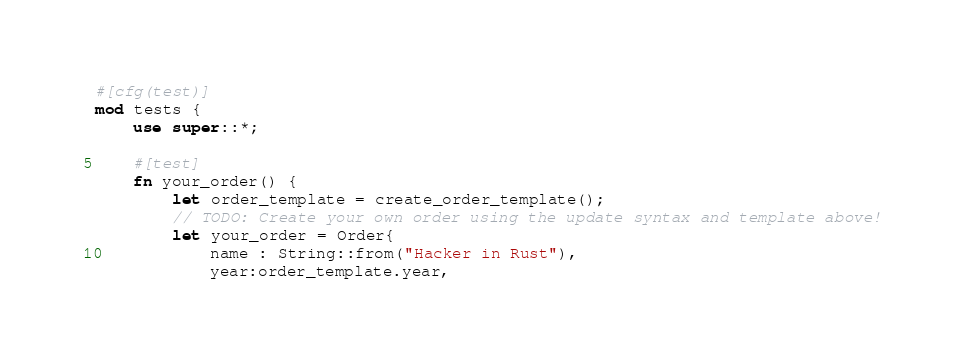Convert code to text. <code><loc_0><loc_0><loc_500><loc_500><_Rust_>#[cfg(test)]
mod tests {
    use super::*;

    #[test]
    fn your_order() {
        let order_template = create_order_template();
        // TODO: Create your own order using the update syntax and template above!
        let your_order = Order{
            name : String::from("Hacker in Rust"),
            year:order_template.year,</code> 